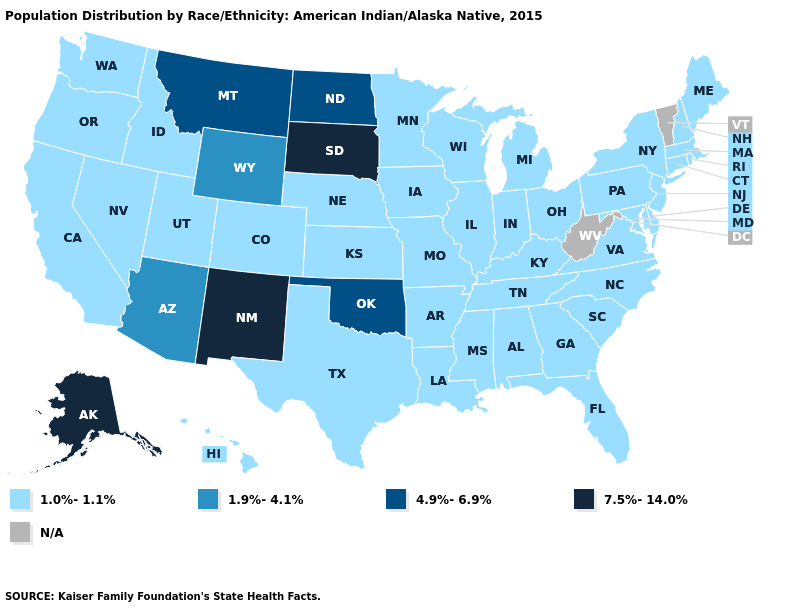Does Wyoming have the lowest value in the USA?
Quick response, please. No. Name the states that have a value in the range 4.9%-6.9%?
Write a very short answer. Montana, North Dakota, Oklahoma. What is the value of West Virginia?
Keep it brief. N/A. What is the value of South Dakota?
Give a very brief answer. 7.5%-14.0%. Does North Carolina have the highest value in the USA?
Quick response, please. No. What is the value of South Carolina?
Keep it brief. 1.0%-1.1%. Does the map have missing data?
Answer briefly. Yes. Does Arkansas have the lowest value in the South?
Answer briefly. Yes. What is the highest value in states that border Oregon?
Write a very short answer. 1.0%-1.1%. Does New Mexico have the highest value in the USA?
Concise answer only. Yes. How many symbols are there in the legend?
Be succinct. 5. Is the legend a continuous bar?
Keep it brief. No. What is the value of Kentucky?
Give a very brief answer. 1.0%-1.1%. Name the states that have a value in the range 1.0%-1.1%?
Quick response, please. Alabama, Arkansas, California, Colorado, Connecticut, Delaware, Florida, Georgia, Hawaii, Idaho, Illinois, Indiana, Iowa, Kansas, Kentucky, Louisiana, Maine, Maryland, Massachusetts, Michigan, Minnesota, Mississippi, Missouri, Nebraska, Nevada, New Hampshire, New Jersey, New York, North Carolina, Ohio, Oregon, Pennsylvania, Rhode Island, South Carolina, Tennessee, Texas, Utah, Virginia, Washington, Wisconsin. 